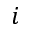<formula> <loc_0><loc_0><loc_500><loc_500>i</formula> 